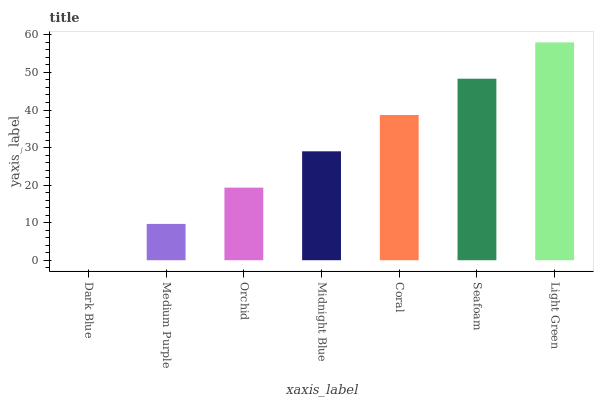Is Dark Blue the minimum?
Answer yes or no. Yes. Is Light Green the maximum?
Answer yes or no. Yes. Is Medium Purple the minimum?
Answer yes or no. No. Is Medium Purple the maximum?
Answer yes or no. No. Is Medium Purple greater than Dark Blue?
Answer yes or no. Yes. Is Dark Blue less than Medium Purple?
Answer yes or no. Yes. Is Dark Blue greater than Medium Purple?
Answer yes or no. No. Is Medium Purple less than Dark Blue?
Answer yes or no. No. Is Midnight Blue the high median?
Answer yes or no. Yes. Is Midnight Blue the low median?
Answer yes or no. Yes. Is Medium Purple the high median?
Answer yes or no. No. Is Medium Purple the low median?
Answer yes or no. No. 